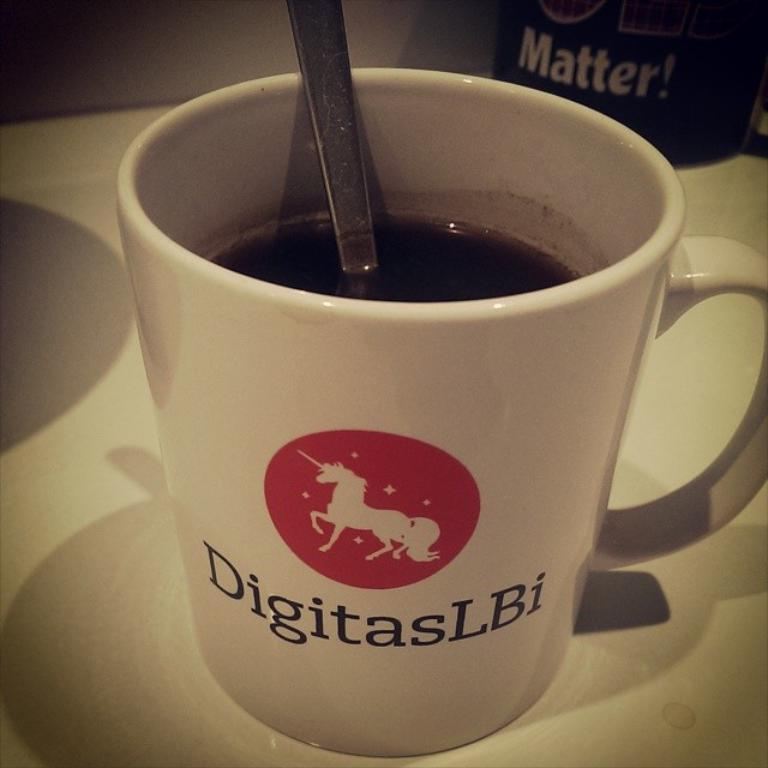Provide a one-sentence caption for the provided image. A coffee cup with the image of a unicorn and DigitasLBI on it. 